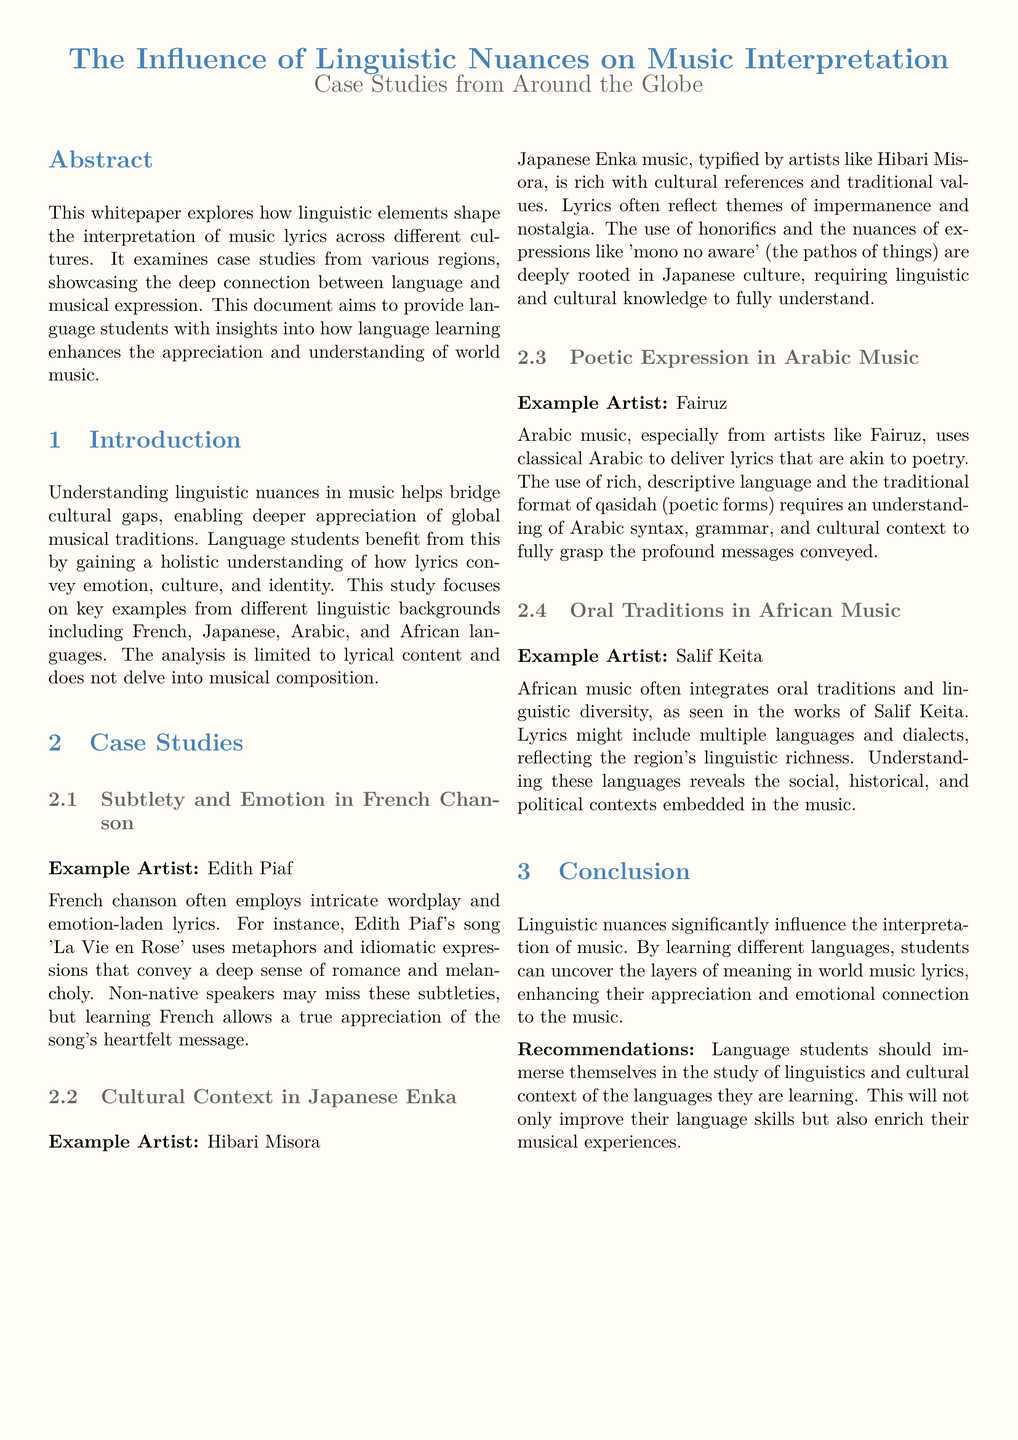What is the main focus of the whitepaper? The whitepaper explores how linguistic elements shape the interpretation of music lyrics across different cultures.
Answer: Linguistic elements and music interpretation Which artist is associated with French chanson in the case study? The case study on French chanson mentions Edith Piaf as the example artist.
Answer: Edith Piaf What lyrical theme is highlighted in Japanese Enka music? The case study emphasizes themes of impermanence and nostalgia in Japanese Enka music.
Answer: Impermanence and nostalgia What is the term used in Japanese culture that reflects emotional nuance? The document refers to the term "mono no aware" when discussing emotional nuance in Japanese lyrics.
Answer: Mono no aware How does Arabic music convey its lyrical messages? The whitepaper states that Arabic music uses classical Arabic to deliver lyrics akin to poetry.
Answer: Classical Arabic Who is the example artist for African music in the document? The document lists Salif Keita as the artist exemplifying African music.
Answer: Salif Keita What is one of the recommendations for language students? The recommendations suggest that language students immerse themselves in the study of linguistics and cultural context.
Answer: Study of linguistics and cultural context What type of lyrical content does the whitepaper limit its analysis to? The analysis in the whitepaper is limited to lyrical content, not musical composition.
Answer: Lyrical content What is the ultimate goal of enhancing appreciation of world music? The ultimate goal is to uncover the layers of meaning in world music lyrics.
Answer: Uncover layers of meaning 